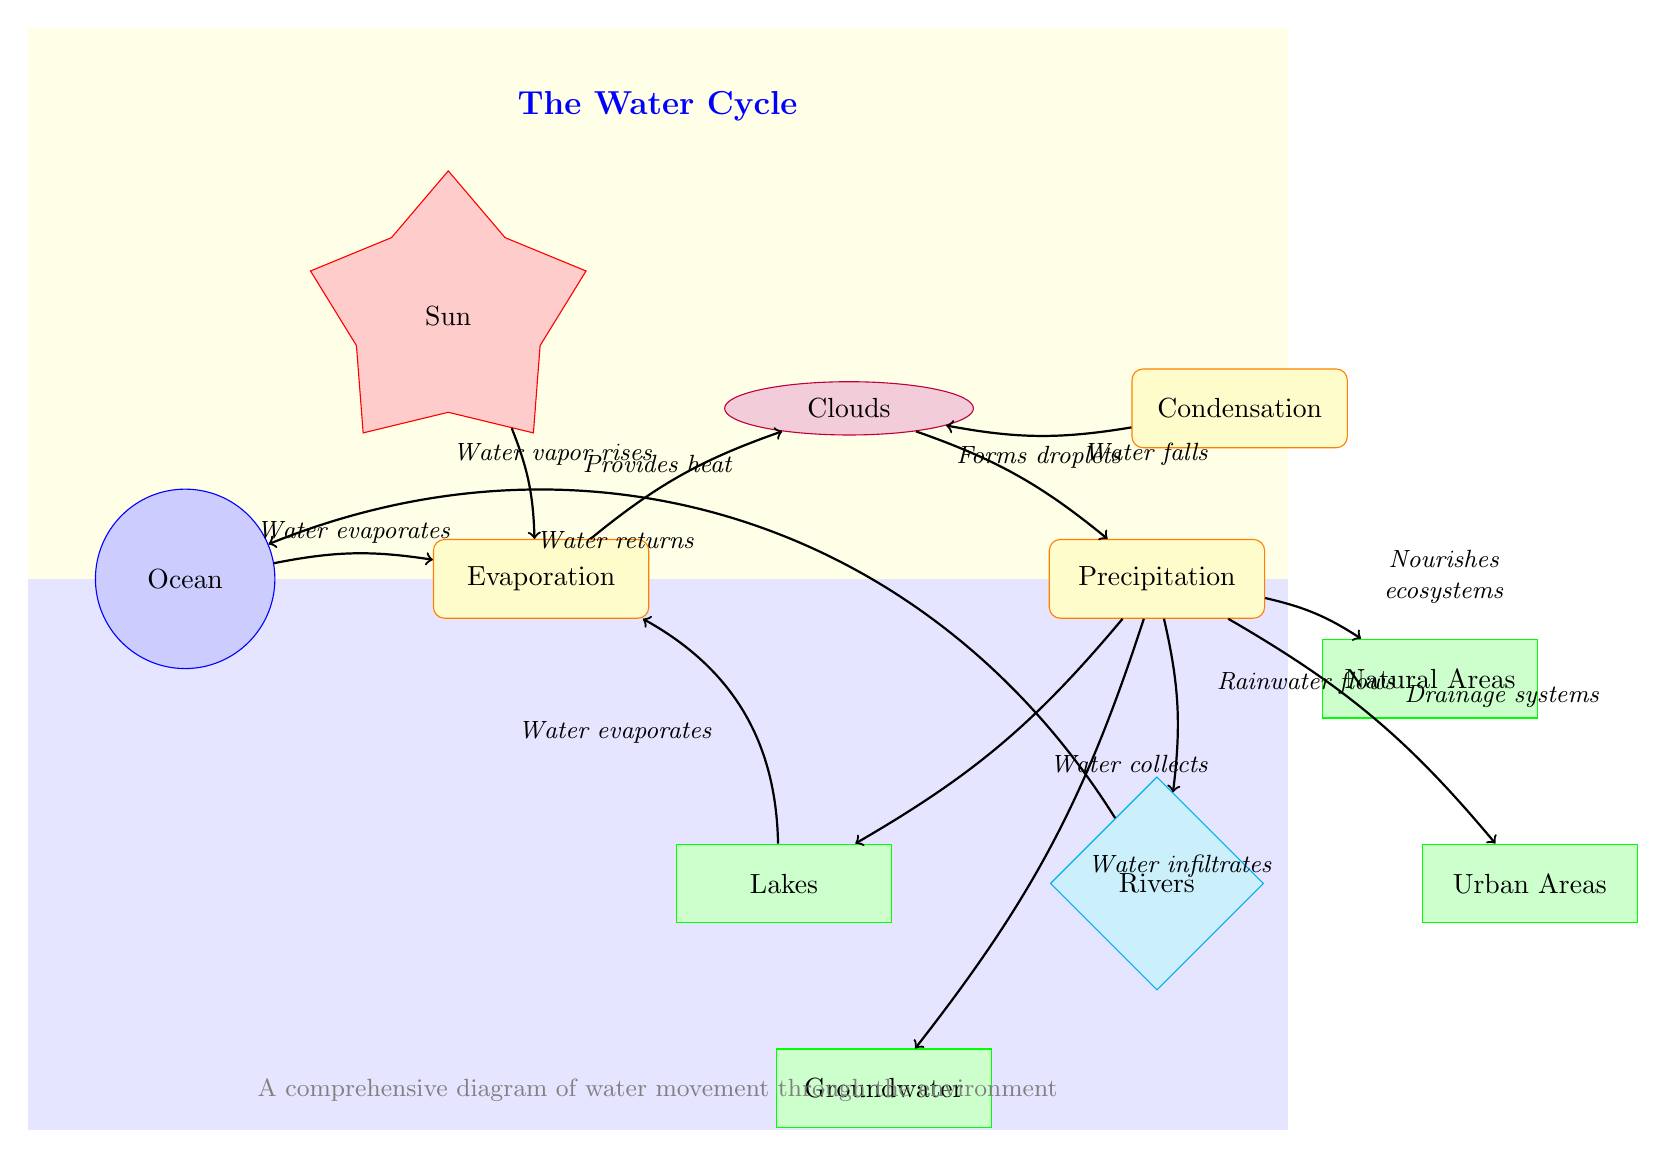What is the primary source of energy for evaporation? The diagram indicates that the Sun provides heat, which is essential for the evaporation process. Therefore, by identifying the node designated as the source and its connection to evaporation, we conclude that the Sun plays a crucial role in this phase of the water cycle.
Answer: Sun How many types of collection areas are shown in the diagram? By examining the diagram for nodes labeled as collection areas, we can identify four specific types: Groundwater, Lakes, Urban Areas, and Natural Areas. Counting these gives us a total of four distinct collection areas in the water cycle.
Answer: 4 What process occurs directly after condensation? The diagram shows that precipitation follows condensation, indicating that once water vapor condenses into droplets, it subsequently falls as precipitation. This can be verified by tracing the flow from the condensation node to the precipitation node.
Answer: Precipitation What happens to rainwater after precipitation? According to the diagram, rainwater flows into rivers after precipitation occurs. This connection is explicitly drawn in the diagram, illustrating the path rainwater takes in the water cycle following precipitation.
Answer: Rivers Which element nourishes ecosystems according to the diagram? The diagram specifies that water from precipitation nourishes ecosystems, highlighting the role of water in maintaining natural habitats. This connection can be seen by following the path from precipitation to natural areas.
Answer: Natural Areas What process involves water forming droplets? The diagram indicates that condensation is the process in which water vapor forms droplets. This is part of the water cycle, where water transitions from vapor to liquid form. Therefore, pinpointing the relevant node clarifies that condensation is the process in question.
Answer: Condensation How does water return to the ocean according to the diagram? The diagram shows that water returns to the ocean through rivers. After precipitation, rainwater flows into rivers, and from there, the flow indicates a return path back to the ocean. By tracing these paths, we confirm that rivers are the route for water’s return to the ocean.
Answer: Rivers What does the sun provide to facilitate evaporation? The diagram clarifies that the sun provides heat, which is necessary for the evaporation process to occur. By looking at the connection from the sun to evaporation, we see that heat is a critical factor in this part of the cycle.
Answer: Heat 